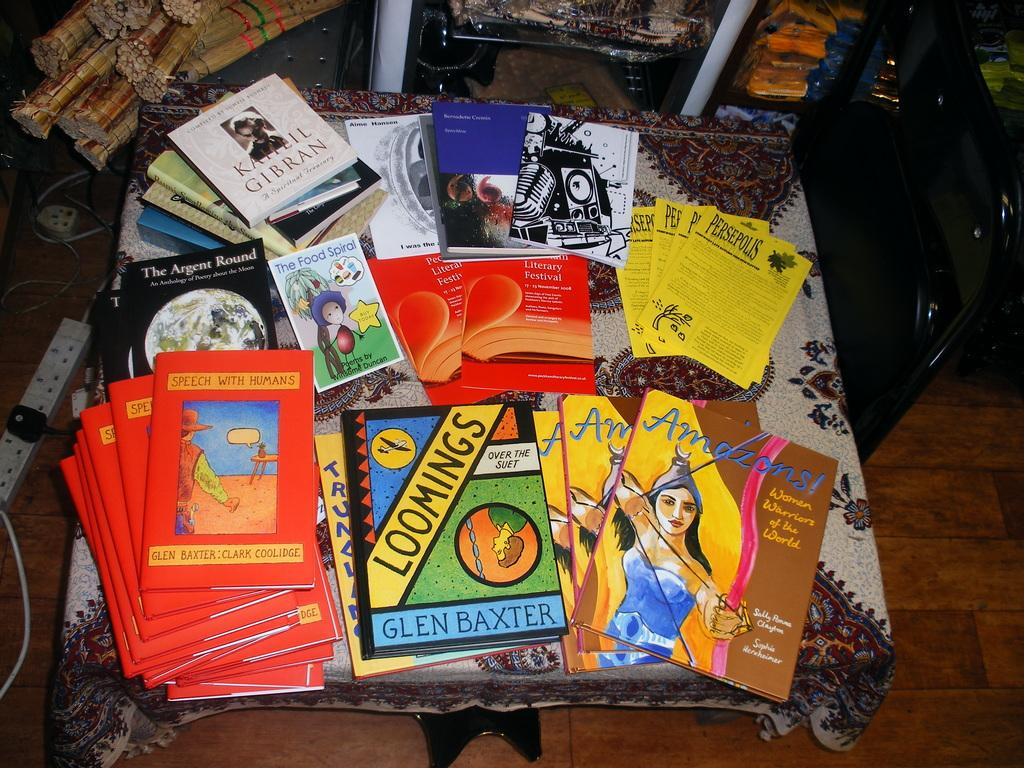<image>
Render a clear and concise summary of the photo. A book called Loomings sits on a table with several other books 